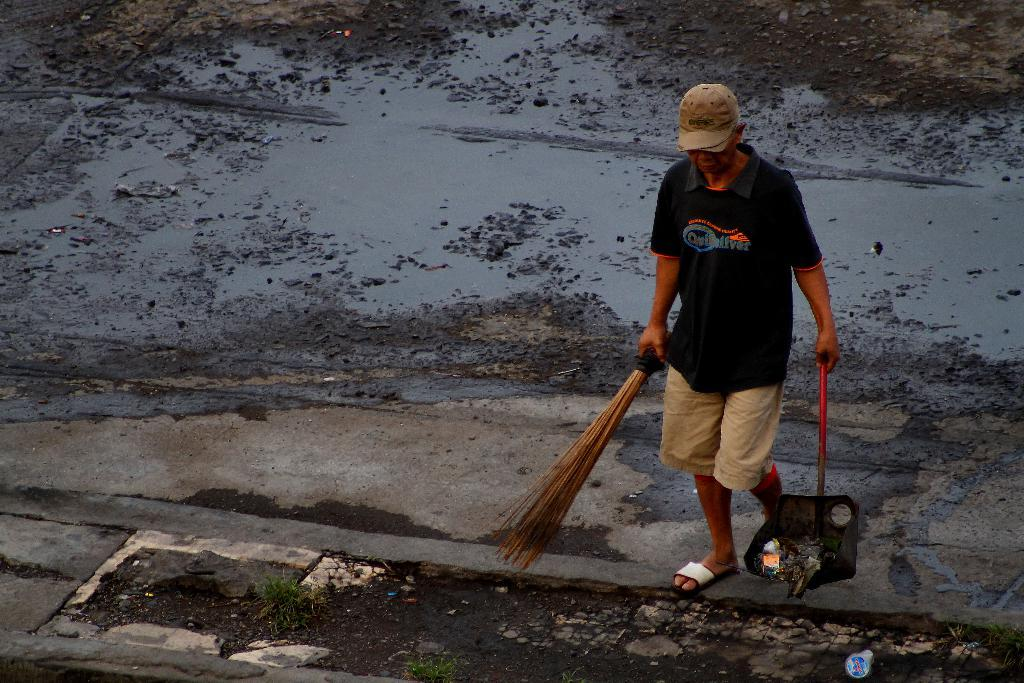What can be seen in the image? There is a person in the image. What is the person wearing? The person is wearing a T-shirt and a cap. What is the person holding? The person is holding a broomstick. What object is present near the person? A dust tray is present in the image, and the person is standing near it. What is the condition of the road in the image? There is muddy water on the road in the image. What type of beast is present in the image? There is no beast present in the image; it features a person holding a broomstick and standing near a dust tray. What type of desk is visible in the image? There is no desk present in the image. 